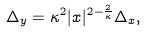Convert formula to latex. <formula><loc_0><loc_0><loc_500><loc_500>\Delta _ { y } = \kappa ^ { 2 } | x | ^ { 2 - \frac { 2 } { \kappa } } \Delta _ { x } ,</formula> 